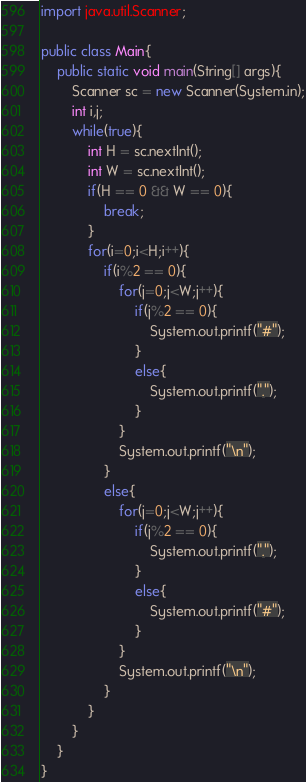Convert code to text. <code><loc_0><loc_0><loc_500><loc_500><_Java_>import java.util.Scanner;

public class Main{
	public static void main(String[] args){
		Scanner sc = new Scanner(System.in);
		int i,j;
		while(true){
			int H = sc.nextInt();
			int W = sc.nextInt();
			if(H == 0 && W == 0){
				break;
			}
			for(i=0;i<H;i++){
				if(i%2 == 0){
					for(j=0;j<W;j++){
						if(j%2 == 0){
							System.out.printf("#");
						}
						else{
							System.out.printf(".");
						}
					}
					System.out.printf("\n");
				}
				else{
					for(j=0;j<W;j++){
						if(j%2 == 0){
							System.out.printf(".");
						}
						else{
							System.out.printf("#");
						}
					}
					System.out.printf("\n");
				}
			}
		}
	}
}</code> 